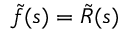<formula> <loc_0><loc_0><loc_500><loc_500>\tilde { f } ( s ) = \tilde { R } ( s )</formula> 